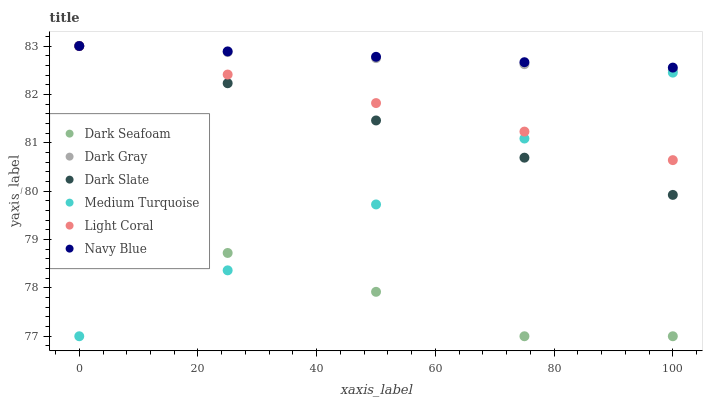Does Dark Seafoam have the minimum area under the curve?
Answer yes or no. Yes. Does Navy Blue have the maximum area under the curve?
Answer yes or no. Yes. Does Dark Gray have the minimum area under the curve?
Answer yes or no. No. Does Dark Gray have the maximum area under the curve?
Answer yes or no. No. Is Dark Slate the smoothest?
Answer yes or no. Yes. Is Dark Seafoam the roughest?
Answer yes or no. Yes. Is Navy Blue the smoothest?
Answer yes or no. No. Is Navy Blue the roughest?
Answer yes or no. No. Does Dark Seafoam have the lowest value?
Answer yes or no. Yes. Does Dark Gray have the lowest value?
Answer yes or no. No. Does Dark Slate have the highest value?
Answer yes or no. Yes. Does Dark Seafoam have the highest value?
Answer yes or no. No. Is Dark Seafoam less than Light Coral?
Answer yes or no. Yes. Is Navy Blue greater than Dark Seafoam?
Answer yes or no. Yes. Does Dark Slate intersect Medium Turquoise?
Answer yes or no. Yes. Is Dark Slate less than Medium Turquoise?
Answer yes or no. No. Is Dark Slate greater than Medium Turquoise?
Answer yes or no. No. Does Dark Seafoam intersect Light Coral?
Answer yes or no. No. 